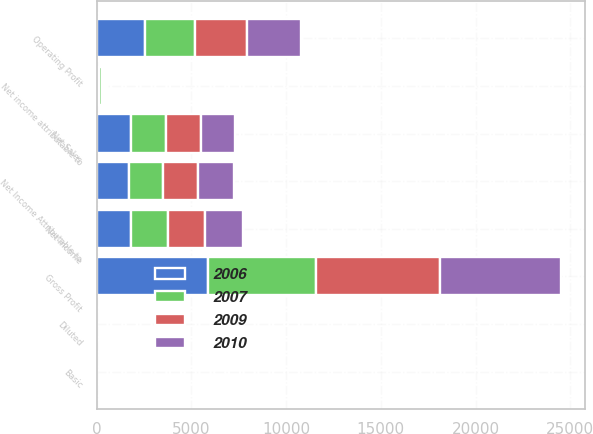Convert chart to OTSL. <chart><loc_0><loc_0><loc_500><loc_500><stacked_bar_chart><ecel><fcel>Net Sales<fcel>Gross Profit<fcel>Operating Profit<fcel>Net Income<fcel>Net income attributable to<fcel>Net Income Attributable to<fcel>Basic<fcel>Diluted<nl><fcel>2009<fcel>1826<fcel>6550<fcel>2773<fcel>1943<fcel>100<fcel>1843<fcel>4.47<fcel>4.45<nl><fcel>2010<fcel>1826<fcel>6420<fcel>2825<fcel>1994<fcel>110<fcel>1884<fcel>4.53<fcel>4.52<nl><fcel>2006<fcel>1826<fcel>5858<fcel>2547<fcel>1829<fcel>139<fcel>1690<fcel>4.04<fcel>4.03<nl><fcel>2007<fcel>1826<fcel>5704<fcel>2616<fcel>1951<fcel>128<fcel>1823<fcel>4.11<fcel>4.08<nl></chart> 